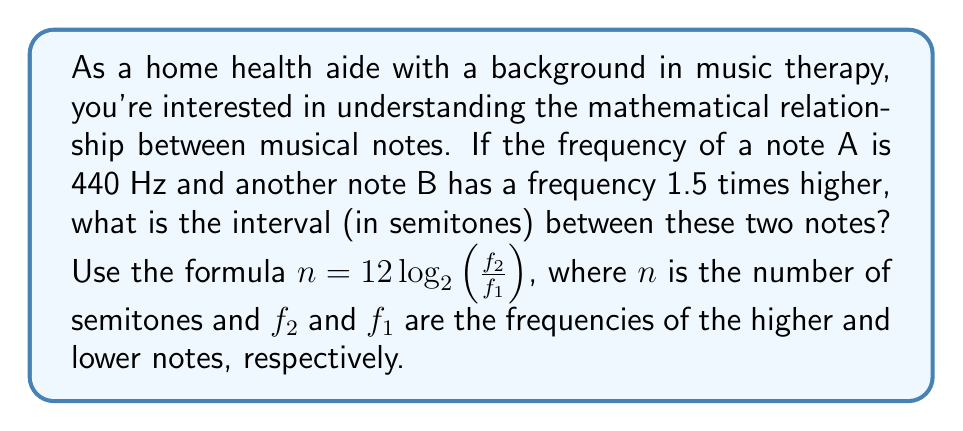What is the answer to this math problem? Let's approach this step-by-step:

1) We're given that the frequency of note A ($f_1$) is 440 Hz.

2) The frequency of note B ($f_2$) is 1.5 times higher, so:
   $f_2 = 1.5 \times 440 = 660$ Hz

3) We'll use the formula: $n = 12 \log_2(\frac{f_2}{f_1})$

4) Substituting our values:
   $n = 12 \log_2(\frac{660}{440})$

5) Simplify inside the logarithm:
   $n = 12 \log_2(1.5)$

6) Now, we need to calculate $\log_2(1.5)$. We can use the change of base formula:
   $\log_2(1.5) = \frac{\log(1.5)}{\log(2)}$

7) Using a calculator or computer:
   $\log(1.5) \approx 0.4054651081$
   $\log(2) \approx 0.6931471806$

8) Divide:
   $\frac{0.4054651081}{0.6931471806} \approx 0.5849625007$

9) Multiply by 12:
   $12 \times 0.5849625007 \approx 7.0195500084$

10) Rounding to the nearest whole number (as semitones are whole number intervals):
    $n \approx 7$

Therefore, the interval between the two notes is approximately 7 semitones.
Answer: 7 semitones 